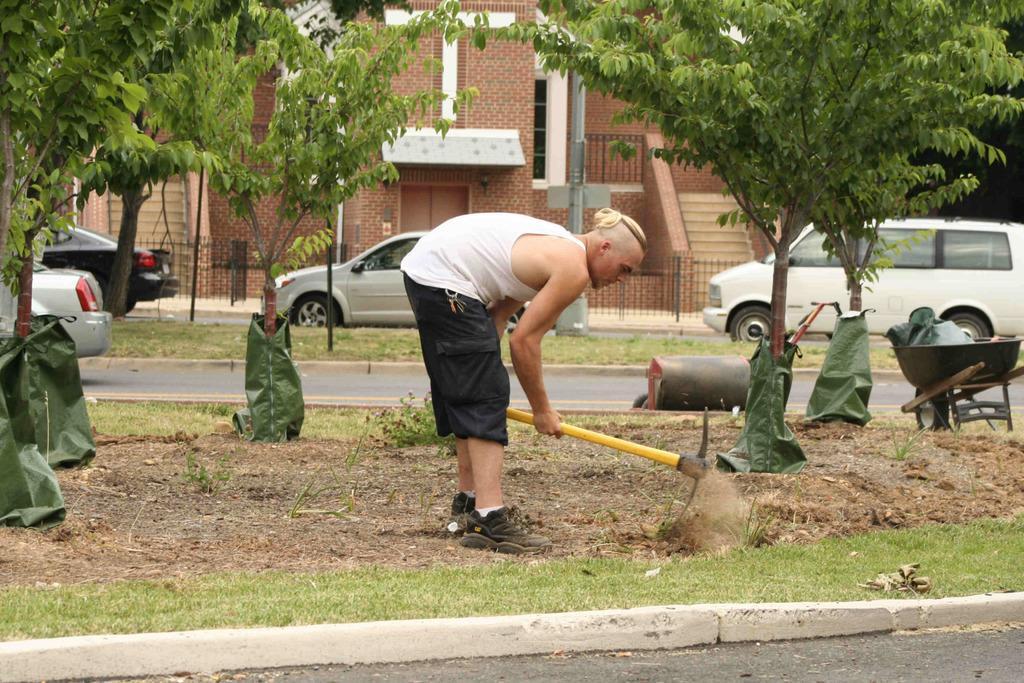Please provide a concise description of this image. This picture shows trees and few cars and a van parked and we see a building and a man digging the ground with an instrument and we see grass on the ground and bags to the tree barks. 